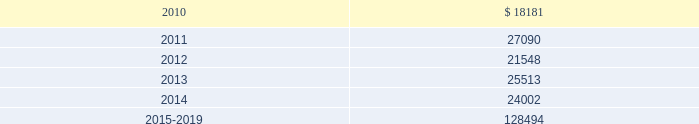Mastercard incorporated notes to consolidated financial statements 2014 ( continued ) ( in thousands , except percent and per share data ) the table summarizes expected benefit payments through 2019 for the pension plans , including those payments expected to be paid from the company 2019s general assets .
Since the majority of the benefit payments are made in the form of lump-sum distributions , actual benefit payments may differ from expected benefit payments. .
Substantially all of the company 2019s u.s .
Employees are eligible to participate in a defined contribution savings plan ( the 201csavings plan 201d ) sponsored by the company .
The savings plan allows employees to contribute a portion of their base compensation on a pre-tax and after-tax basis in accordance with specified guidelines .
The company matches a percentage of employees 2019 contributions up to certain limits .
In 2007 and prior years , the company could also contribute to the savings plan a discretionary profit sharing component linked to company performance during the prior year .
Beginning in 2008 , the discretionary profit sharing amount related to prior year company performance was paid directly to employees as a short-term cash incentive bonus rather than as a contribution to the savings plan .
In addition , the company has several defined contribution plans outside of the united states .
The company 2019s contribution expense related to all of its defined contribution plans was $ 40627 , $ 35341 and $ 26996 for 2009 , 2008 and 2007 , respectively .
Note 13 .
Postemployment and postretirement benefits the company maintains a postretirement plan ( the 201cpostretirement plan 201d ) providing health coverage and life insurance benefits for substantially all of its u.s .
Employees hired before july 1 , 2007 .
The company amended the life insurance benefits under the postretirement plan effective january 1 , 2007 .
The impact , net of taxes , of this amendment was an increase of $ 1715 to accumulated other comprehensive income in 2007 .
In 2009 , the company recorded a $ 3944 benefit expense as a result of enhanced postretirement medical benefits under the postretirement plan provided to employees that chose to participate in a voluntary transition program. .
What is the average contribution expense related to all of its defined contribution plans for the years 2007-2009? 
Rationale: it is the sum of all contribution expenses in these years divided by three .
Computations: ((26996 + (40627 + 35341)) / 3)
Answer: 34321.33333. 